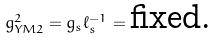Convert formula to latex. <formula><loc_0><loc_0><loc_500><loc_500>g _ { Y M 2 } ^ { 2 } = g _ { s } \ell _ { s } ^ { - 1 } = \text {fixed.}</formula> 